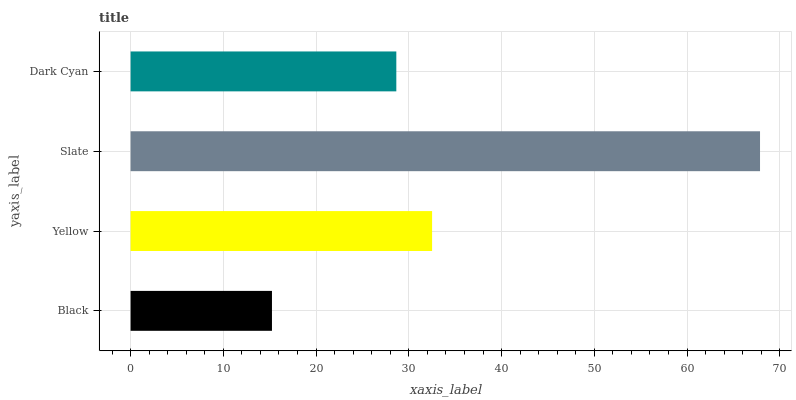Is Black the minimum?
Answer yes or no. Yes. Is Slate the maximum?
Answer yes or no. Yes. Is Yellow the minimum?
Answer yes or no. No. Is Yellow the maximum?
Answer yes or no. No. Is Yellow greater than Black?
Answer yes or no. Yes. Is Black less than Yellow?
Answer yes or no. Yes. Is Black greater than Yellow?
Answer yes or no. No. Is Yellow less than Black?
Answer yes or no. No. Is Yellow the high median?
Answer yes or no. Yes. Is Dark Cyan the low median?
Answer yes or no. Yes. Is Black the high median?
Answer yes or no. No. Is Black the low median?
Answer yes or no. No. 